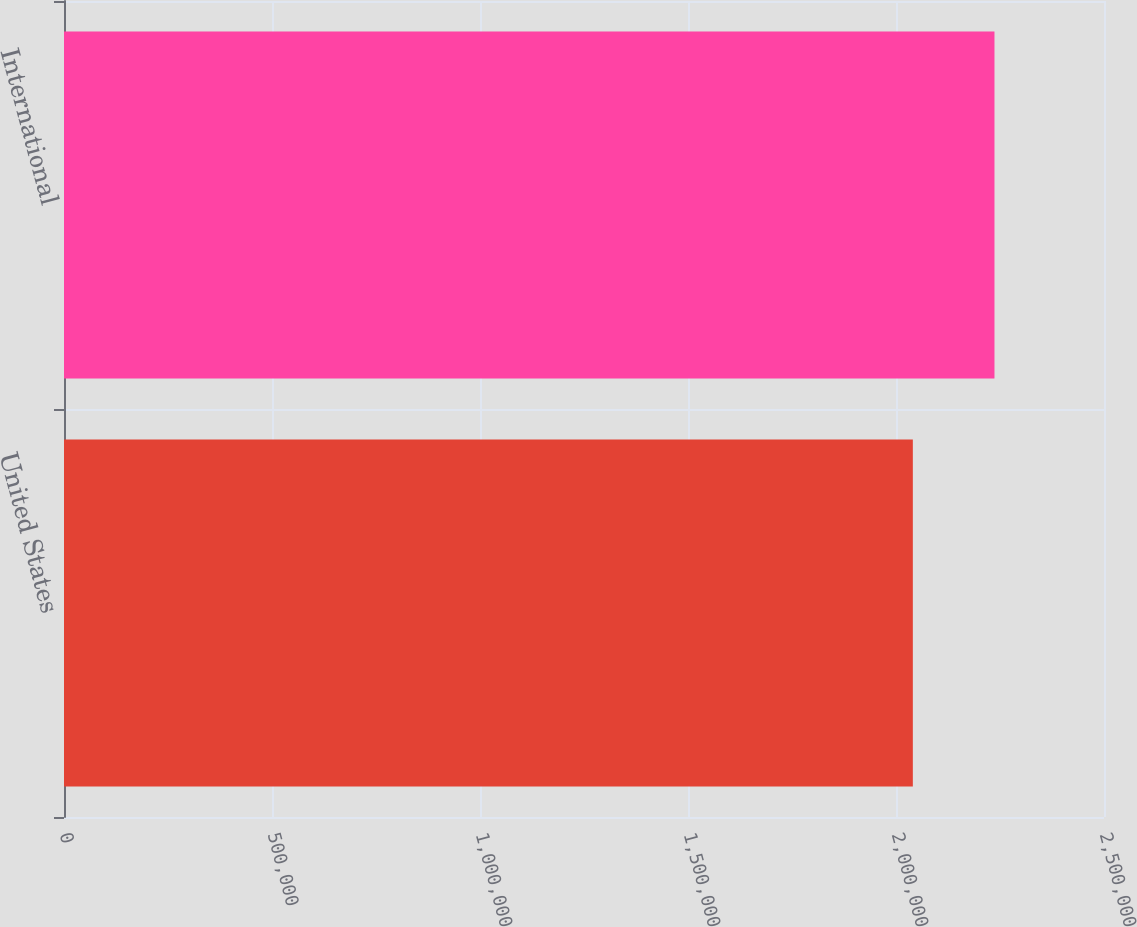<chart> <loc_0><loc_0><loc_500><loc_500><bar_chart><fcel>United States<fcel>International<nl><fcel>2.04048e+06<fcel>2.23673e+06<nl></chart> 